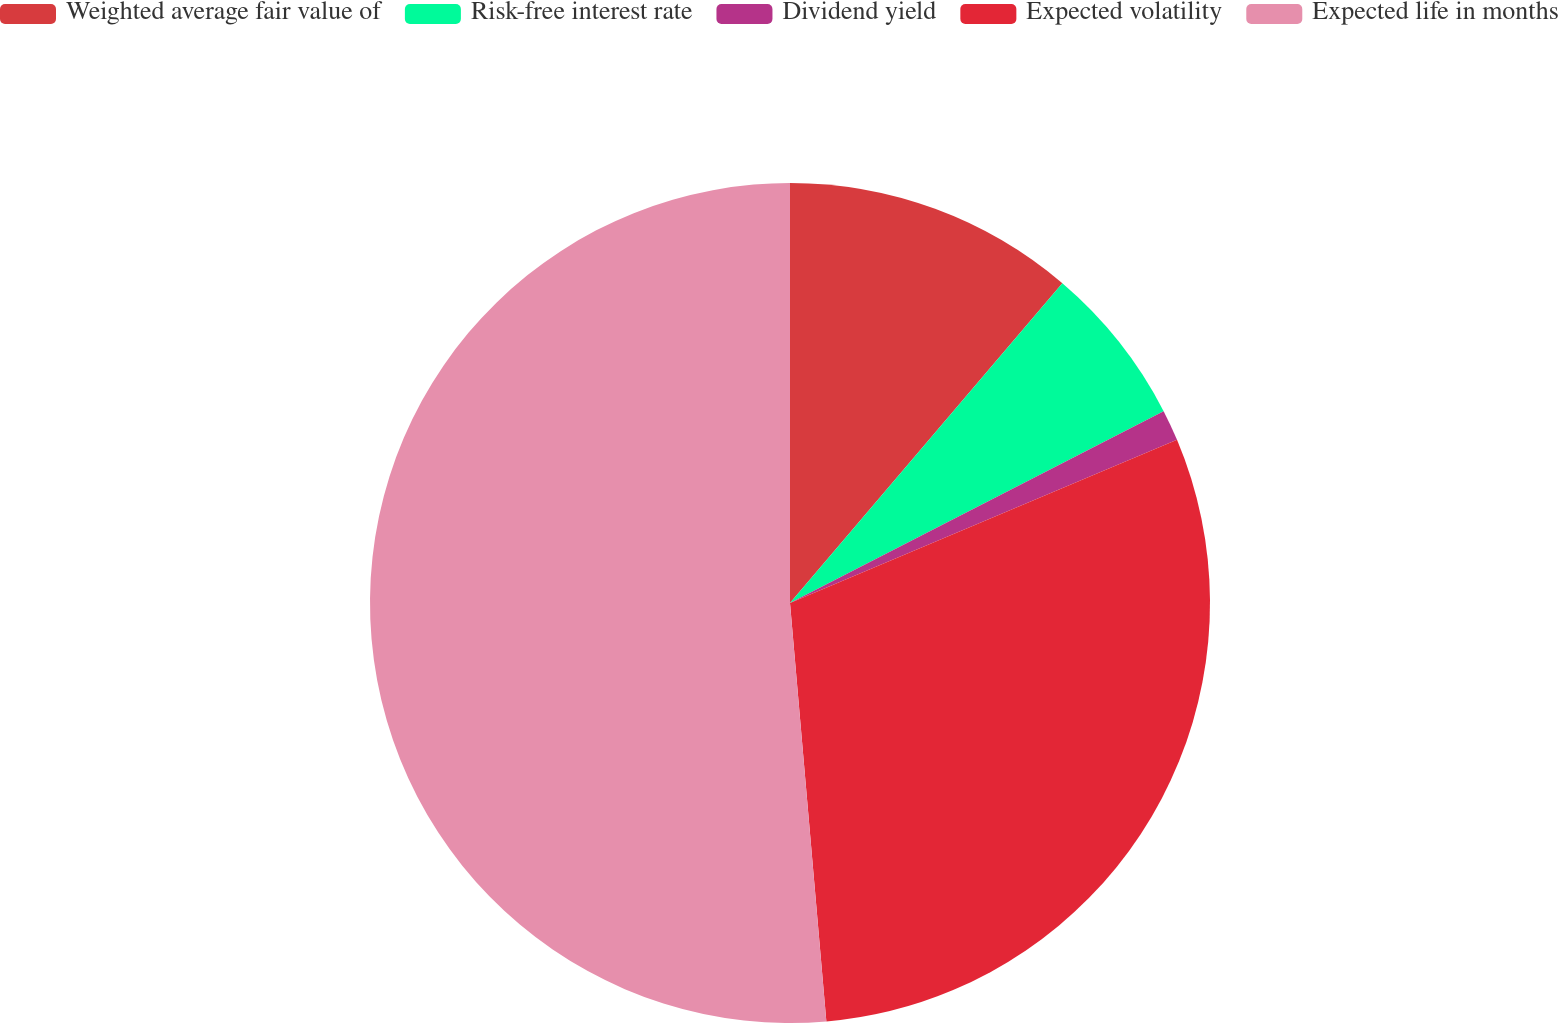<chart> <loc_0><loc_0><loc_500><loc_500><pie_chart><fcel>Weighted average fair value of<fcel>Risk-free interest rate<fcel>Dividend yield<fcel>Expected volatility<fcel>Expected life in months<nl><fcel>11.23%<fcel>6.22%<fcel>1.2%<fcel>29.97%<fcel>51.38%<nl></chart> 